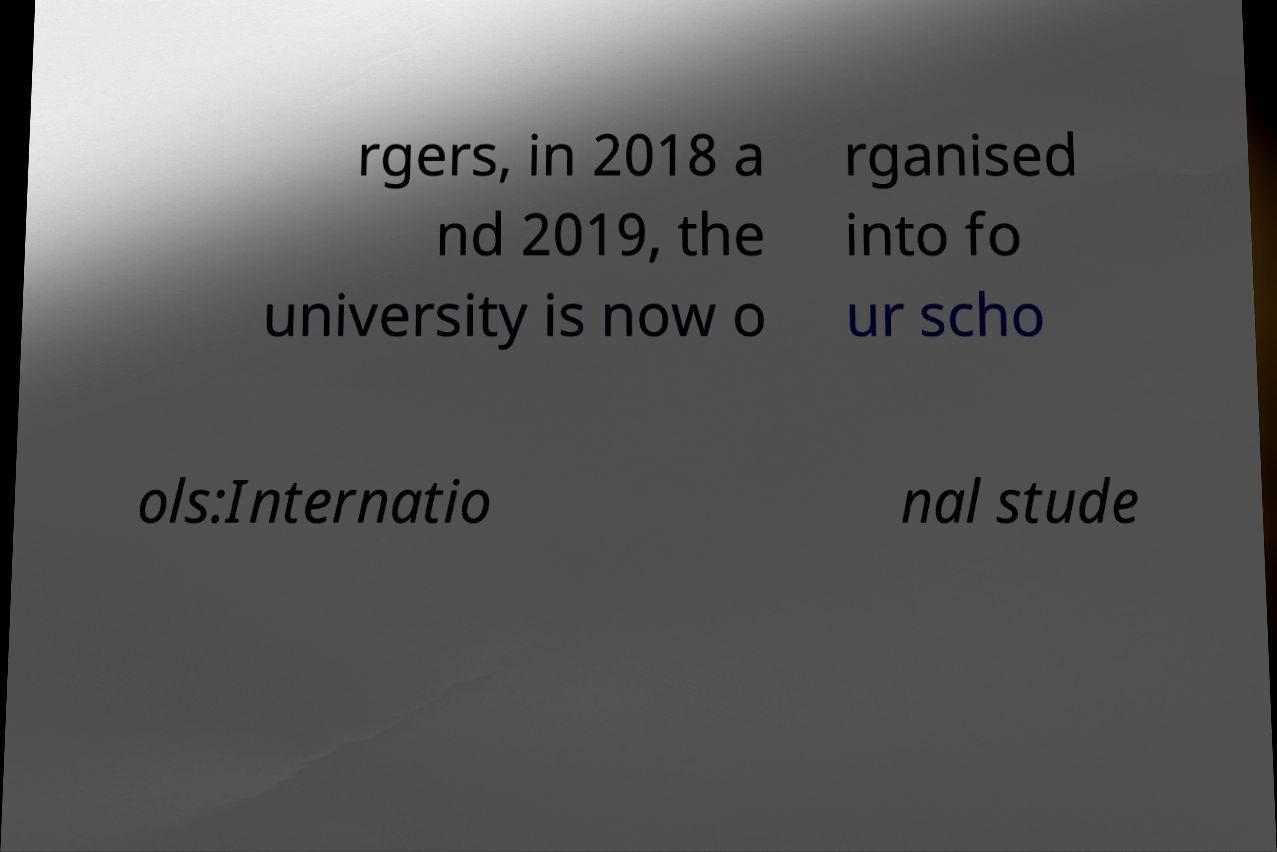Please read and relay the text visible in this image. What does it say? rgers, in 2018 a nd 2019, the university is now o rganised into fo ur scho ols:Internatio nal stude 